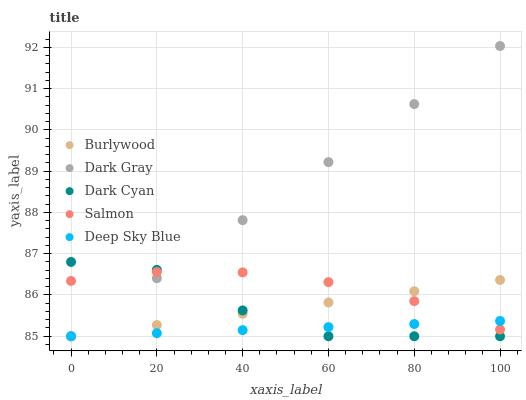Does Deep Sky Blue have the minimum area under the curve?
Answer yes or no. Yes. Does Dark Gray have the maximum area under the curve?
Answer yes or no. Yes. Does Salmon have the minimum area under the curve?
Answer yes or no. No. Does Salmon have the maximum area under the curve?
Answer yes or no. No. Is Dark Gray the smoothest?
Answer yes or no. Yes. Is Dark Cyan the roughest?
Answer yes or no. Yes. Is Salmon the smoothest?
Answer yes or no. No. Is Salmon the roughest?
Answer yes or no. No. Does Burlywood have the lowest value?
Answer yes or no. Yes. Does Salmon have the lowest value?
Answer yes or no. No. Does Dark Gray have the highest value?
Answer yes or no. Yes. Does Salmon have the highest value?
Answer yes or no. No. Does Dark Cyan intersect Salmon?
Answer yes or no. Yes. Is Dark Cyan less than Salmon?
Answer yes or no. No. Is Dark Cyan greater than Salmon?
Answer yes or no. No. 